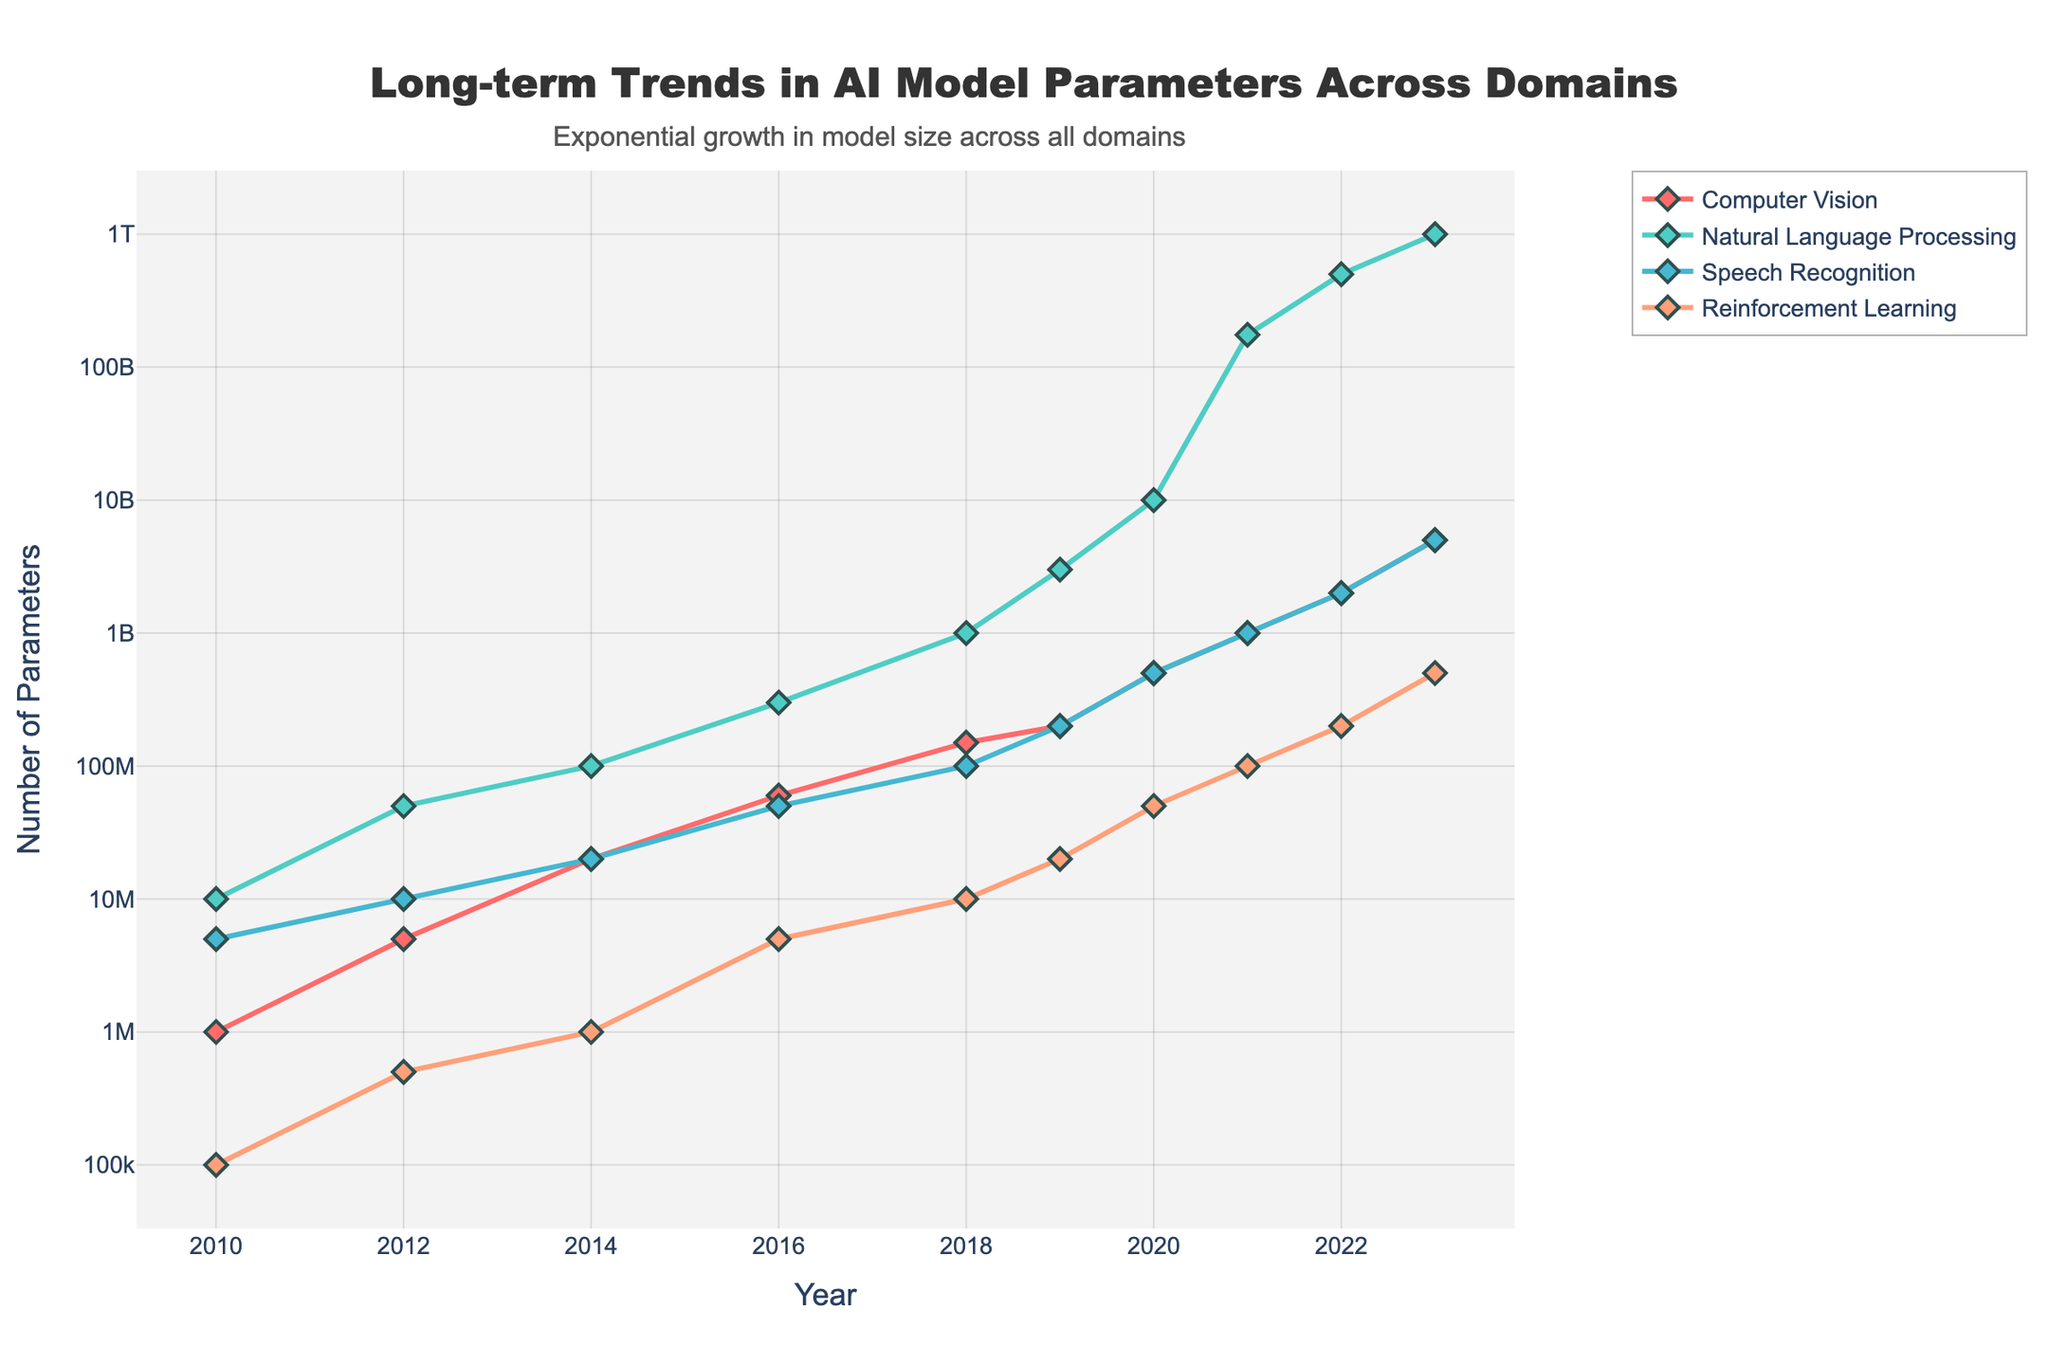What domain experienced the highest growth in the number of parameters between 2010 and 2023? Compare the number of parameters in each domain from 2010 to 2023 and identify the one with the highest increase. The Natural Language Processing domain had 10,000,000 parameters in 2010 and 1,000,000,000,000 in 2023, indicating the highest growth.
Answer: Natural Language Processing Between which years did the Reinforcement Learning domain see the largest increase in the number of parameters? Calculate the difference in the number of parameters for Reinforcement Learning between each consecutive year and find the largest increase. The largest increase occurred between 2021 (100,000,000) and 2022 (200,000,000), which is an increase of 100,000,000 parameters.
Answer: 2021 and 2022 Which domain had the least variation in the number of parameters over the given years? Observe the changes in the number of parameters in each domain and identify the one with the smallest overall increase. Reinforcement Learning started with 100,000 parameters in 2010 and reached 500,000,000 in 2023, which is significant but less compared to other domains.
Answer: Reinforcement Learning By how much did the number of parameters in the Speech Recognition domain increase from 2014 to 2022? Subtract the number of parameters in 2014 (20,000,000) from the number in 2022 (2,000,000,000). This gives an increase of 1,980,000,000 parameters.
Answer: 1,980,000,000 What is the average number of parameters in the Computer Vision domain over all the given years? Add the number of parameters for the Computer Vision domain across all years and divide by the total number of years (10). The sum is 10,876,000,000, and dividing by 10 gives an average of approximately 1,087,600,000 parameters.
Answer: 1,087,600,000 In which year did the Natural Language Processing domain first surpass 1 billion parameters? Look at the values for the Natural Language Processing domain and identify the first year it exceeds 1,000,000,000 parameters. This happened in 2018, with a value of 1,000,000,000.
Answer: 2018 Between 2010 and 2020, which domain had the most stable growth in terms of number of parameters? Evaluate the rate of increase in the number of parameters for each domain and determine which one has the most consistent growth pattern. Computer Vision grew from 1,000,000 to 500,000,000 parameters, showing a steady increase across the years.
Answer: Computer Vision How does the growth rate of parameters in Computer Vision from 2014 to 2016 compare to that in Natural Language Processing during the same period? Calculate the growth rate for both domains. For Computer Vision: (60,000,000 - 20,000,000) / 20,000,000 = 2. For Natural Language Processing: (300,000,000 - 100,000,000) / 100,000,000 = 2. Both domains have the same growth rate of 2.
Answer: They have the same growth rate What color represents the Speech Recognition domain in the chart? Identify the specific visual attribute tied to the Speech Recognition domain by observing its representation in the chart. The color used for Speech Recognition is green.
Answer: Green 